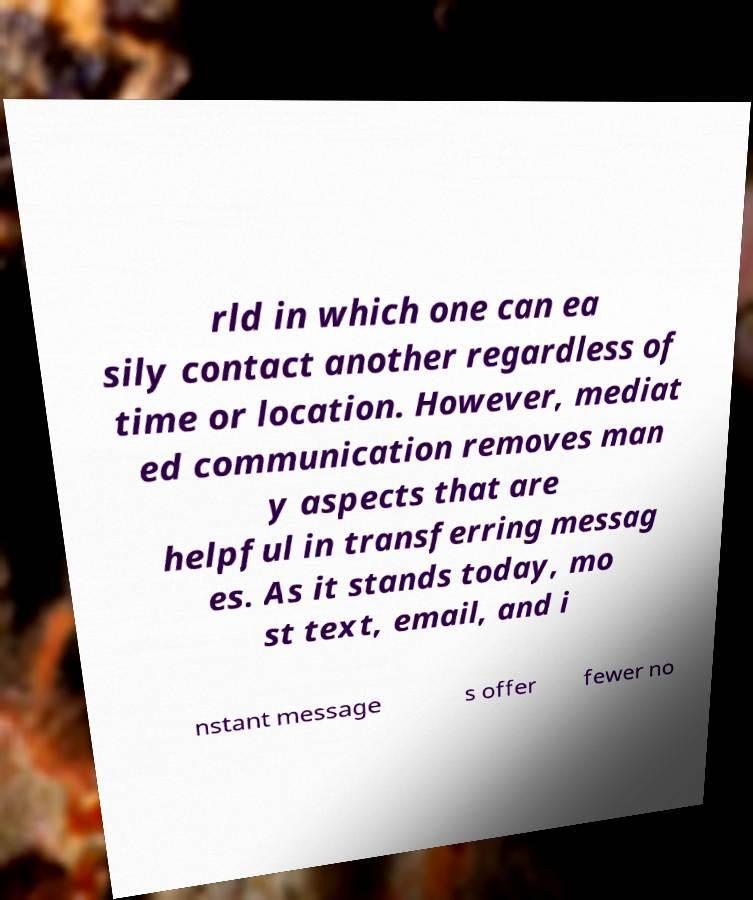There's text embedded in this image that I need extracted. Can you transcribe it verbatim? rld in which one can ea sily contact another regardless of time or location. However, mediat ed communication removes man y aspects that are helpful in transferring messag es. As it stands today, mo st text, email, and i nstant message s offer fewer no 